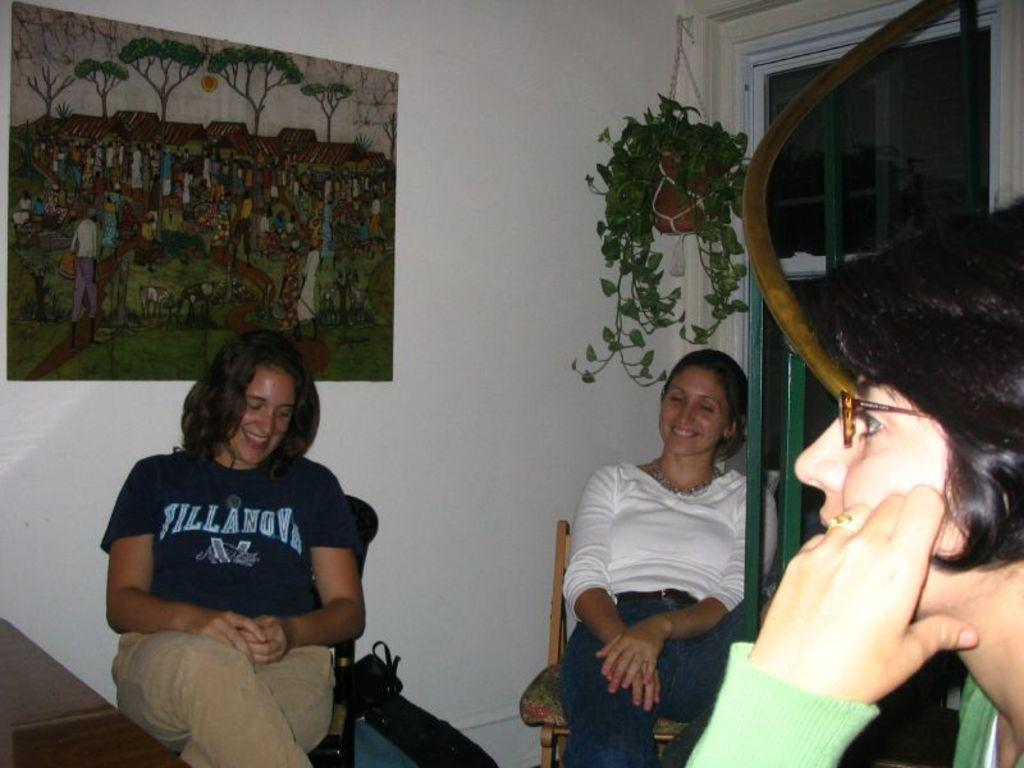How many women are sitting in the image? There are two women sitting in chairs, and another woman is sitting in the right corner of the image. What is visible on the wall behind the women? There is a picture on the wall behind the women. What type of honey is being used to lift the chairs in the image? There is no honey or lifting of chairs in the image; the women are simply sitting in chairs. 